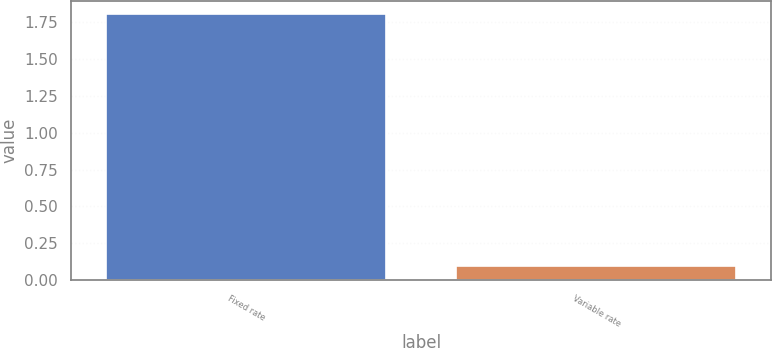<chart> <loc_0><loc_0><loc_500><loc_500><bar_chart><fcel>Fixed rate<fcel>Variable rate<nl><fcel>1.8<fcel>0.1<nl></chart> 